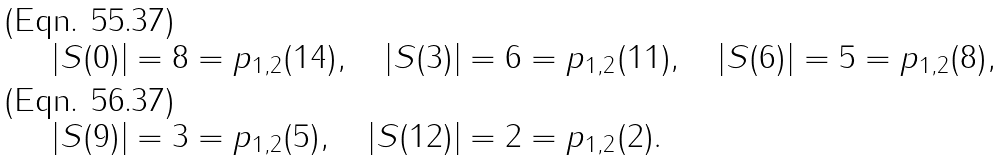Convert formula to latex. <formula><loc_0><loc_0><loc_500><loc_500>| S ( 0 ) | & = 8 = p _ { 1 , 2 } ( 1 4 ) , \quad | S ( 3 ) | = 6 = p _ { 1 , 2 } ( 1 1 ) , \quad | S ( 6 ) | = 5 = p _ { 1 , 2 } ( 8 ) , \\ | S ( 9 ) | & = 3 = p _ { 1 , 2 } ( 5 ) , \quad | S ( 1 2 ) | = 2 = p _ { 1 , 2 } ( 2 ) .</formula> 